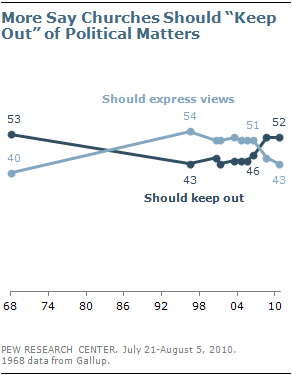Indicate a few pertinent items in this graphic. The largest gap between two lines is 13. The dark line value reaches its peak at 68. 